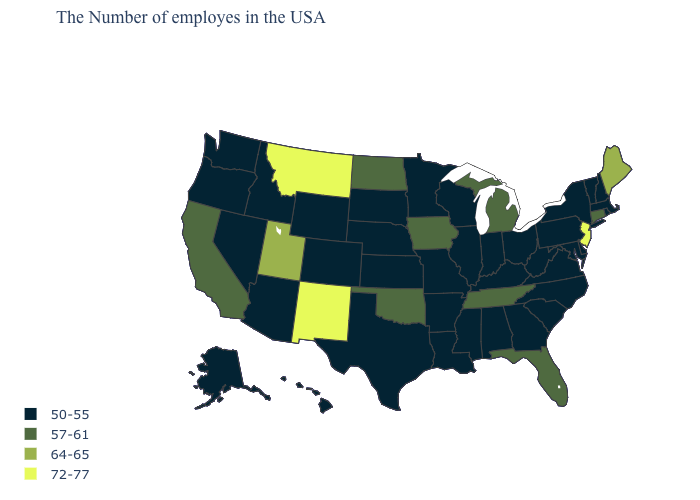What is the value of Rhode Island?
Keep it brief. 50-55. What is the highest value in states that border New Jersey?
Give a very brief answer. 50-55. Among the states that border North Carolina , does South Carolina have the lowest value?
Write a very short answer. Yes. What is the value of Hawaii?
Answer briefly. 50-55. Name the states that have a value in the range 57-61?
Quick response, please. Connecticut, Florida, Michigan, Tennessee, Iowa, Oklahoma, North Dakota, California. Does Connecticut have the highest value in the Northeast?
Be succinct. No. Does New Jersey have a lower value than South Dakota?
Give a very brief answer. No. Which states have the lowest value in the USA?
Give a very brief answer. Massachusetts, Rhode Island, New Hampshire, Vermont, New York, Delaware, Maryland, Pennsylvania, Virginia, North Carolina, South Carolina, West Virginia, Ohio, Georgia, Kentucky, Indiana, Alabama, Wisconsin, Illinois, Mississippi, Louisiana, Missouri, Arkansas, Minnesota, Kansas, Nebraska, Texas, South Dakota, Wyoming, Colorado, Arizona, Idaho, Nevada, Washington, Oregon, Alaska, Hawaii. Name the states that have a value in the range 50-55?
Quick response, please. Massachusetts, Rhode Island, New Hampshire, Vermont, New York, Delaware, Maryland, Pennsylvania, Virginia, North Carolina, South Carolina, West Virginia, Ohio, Georgia, Kentucky, Indiana, Alabama, Wisconsin, Illinois, Mississippi, Louisiana, Missouri, Arkansas, Minnesota, Kansas, Nebraska, Texas, South Dakota, Wyoming, Colorado, Arizona, Idaho, Nevada, Washington, Oregon, Alaska, Hawaii. Which states hav the highest value in the West?
Be succinct. New Mexico, Montana. Among the states that border Oklahoma , does New Mexico have the lowest value?
Give a very brief answer. No. Among the states that border North Carolina , which have the lowest value?
Give a very brief answer. Virginia, South Carolina, Georgia. What is the value of Arizona?
Be succinct. 50-55. Which states have the lowest value in the USA?
Keep it brief. Massachusetts, Rhode Island, New Hampshire, Vermont, New York, Delaware, Maryland, Pennsylvania, Virginia, North Carolina, South Carolina, West Virginia, Ohio, Georgia, Kentucky, Indiana, Alabama, Wisconsin, Illinois, Mississippi, Louisiana, Missouri, Arkansas, Minnesota, Kansas, Nebraska, Texas, South Dakota, Wyoming, Colorado, Arizona, Idaho, Nevada, Washington, Oregon, Alaska, Hawaii. Name the states that have a value in the range 50-55?
Concise answer only. Massachusetts, Rhode Island, New Hampshire, Vermont, New York, Delaware, Maryland, Pennsylvania, Virginia, North Carolina, South Carolina, West Virginia, Ohio, Georgia, Kentucky, Indiana, Alabama, Wisconsin, Illinois, Mississippi, Louisiana, Missouri, Arkansas, Minnesota, Kansas, Nebraska, Texas, South Dakota, Wyoming, Colorado, Arizona, Idaho, Nevada, Washington, Oregon, Alaska, Hawaii. 